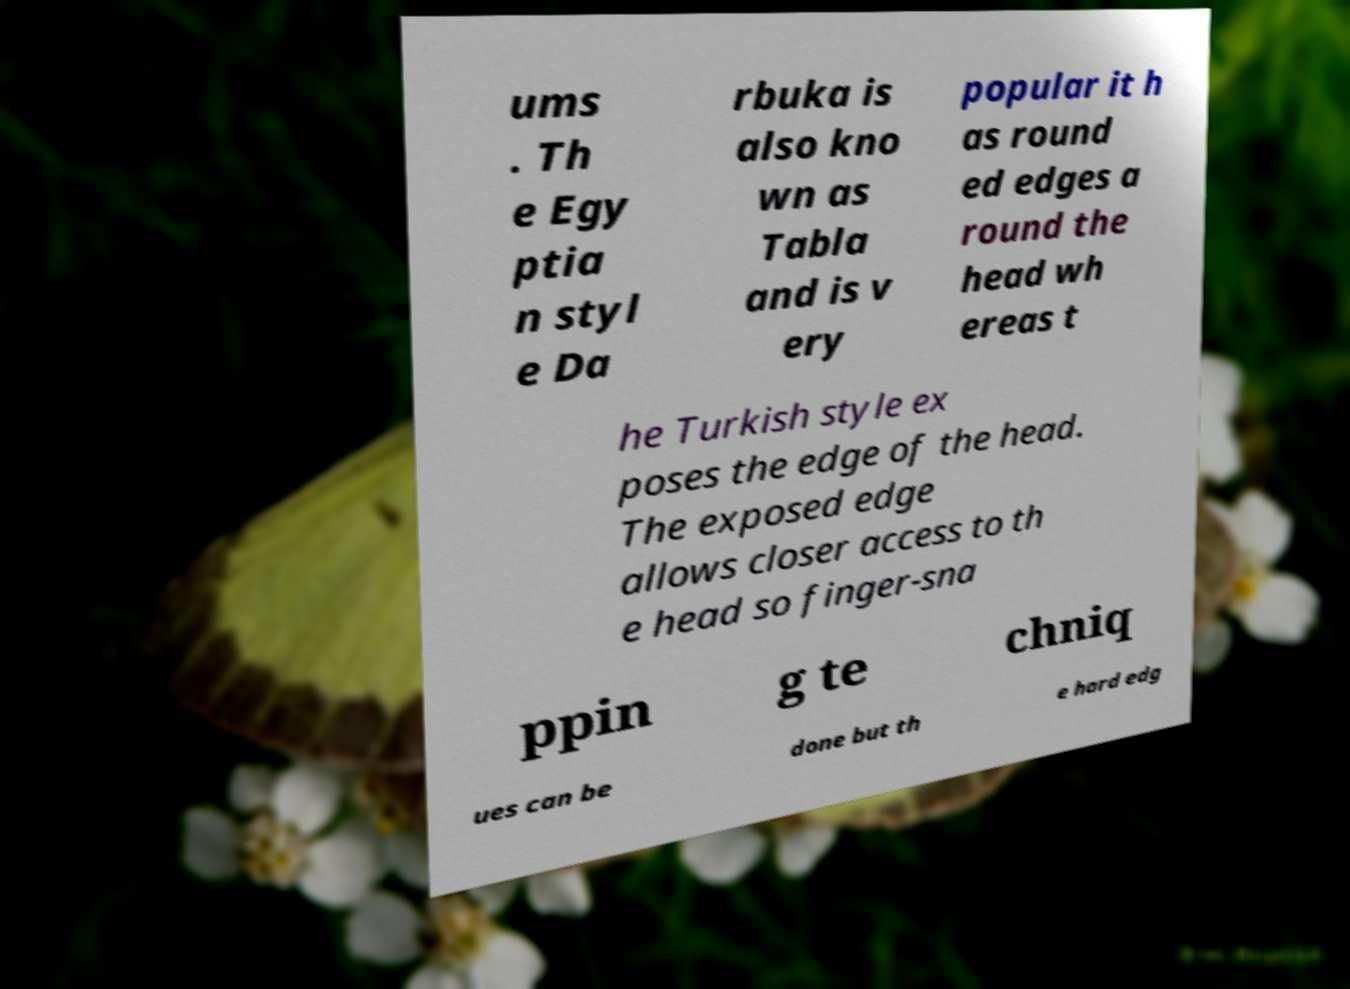Could you extract and type out the text from this image? ums . Th e Egy ptia n styl e Da rbuka is also kno wn as Tabla and is v ery popular it h as round ed edges a round the head wh ereas t he Turkish style ex poses the edge of the head. The exposed edge allows closer access to th e head so finger-sna ppin g te chniq ues can be done but th e hard edg 